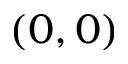Convert formula to latex. <formula><loc_0><loc_0><loc_500><loc_500>( 0 , 0 )</formula> 